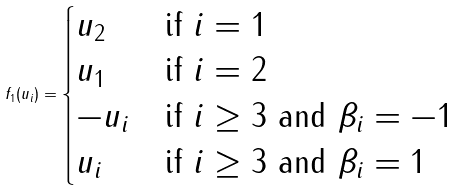<formula> <loc_0><loc_0><loc_500><loc_500>f _ { 1 } ( u _ { i } ) = \begin{cases} u _ { 2 } & \text {if } i = 1 \\ u _ { 1 } & \text {if } i = 2 \\ - u _ { i } & \text {if } i \geq 3 \text { and } \beta _ { i } = - 1 \\ u _ { i } & \text {if } i \geq 3 \text { and } \beta _ { i } = 1 \end{cases}</formula> 